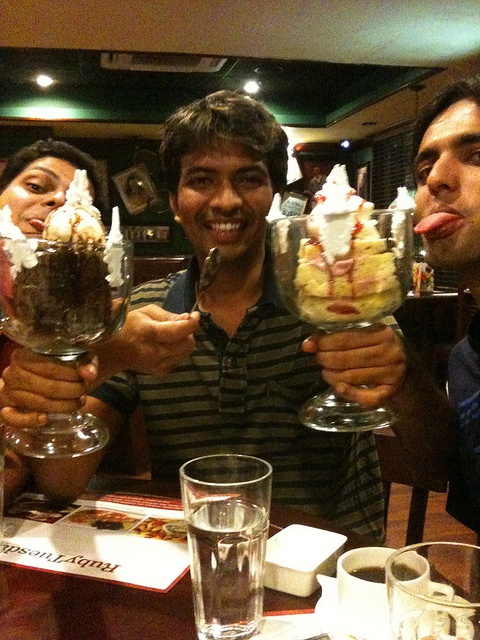Describe the objects in this image and their specific colors. I can see people in maroon, black, and brown tones, people in maroon, black, brown, and tan tones, wine glass in maroon, black, and brown tones, cup in maroon, black, and tan tones, and cake in maroon, black, ivory, and khaki tones in this image. 